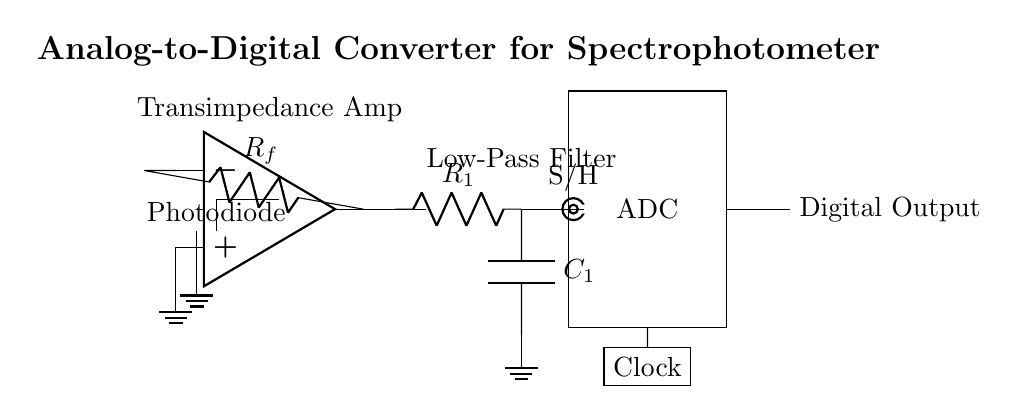What is the role of the photodiode in this circuit? The photodiode converts light into an electrical current, which is the initial step for data acquisition in the spectrophotometer.
Answer: Converts light What type of amplifier is used in the circuit? The circuit includes a transimpedance amplifier, which is specifically designed to convert a small current from the photodiode into a voltage signal.
Answer: Transimpedance amplifier Which component is responsible for filtering high-frequency noise? The low-pass filter, which consists of resistor R1 and capacitor C1, removes high-frequency noise from the signal before it reaches the sample and hold circuit.
Answer: Low-pass filter How does the sample and hold (S/H) circuit function? The sample and hold circuit captures and holds the voltage level from the preceding stages so that the analog-to-digital converter can process a stable voltage for conversion.
Answer: Holds voltage What is the purpose of the clock in the ADC section? The clock provides timing control for the analog-to-digital conversion process, ensuring that the ADC samples the analog signal at consistent intervals.
Answer: Timing control What type of output does the ADC provide? The ADC converts the sampled analog signal into a digital representation, which is expressed as a digital output signal.
Answer: Digital output What is the expected result of the entire circuit's functionality? The expected result is to convert the light intensity data from the spectrophotometer into a digital format that can be used for further analysis or display.
Answer: Digital data conversion 